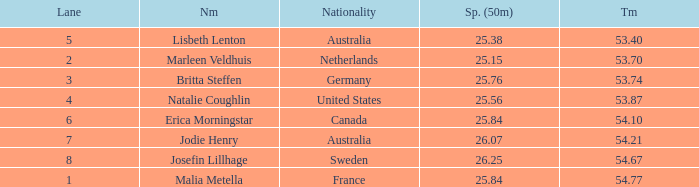What is the slowest 50m split time for a total of 53.74 in a lane of less than 3? None. 